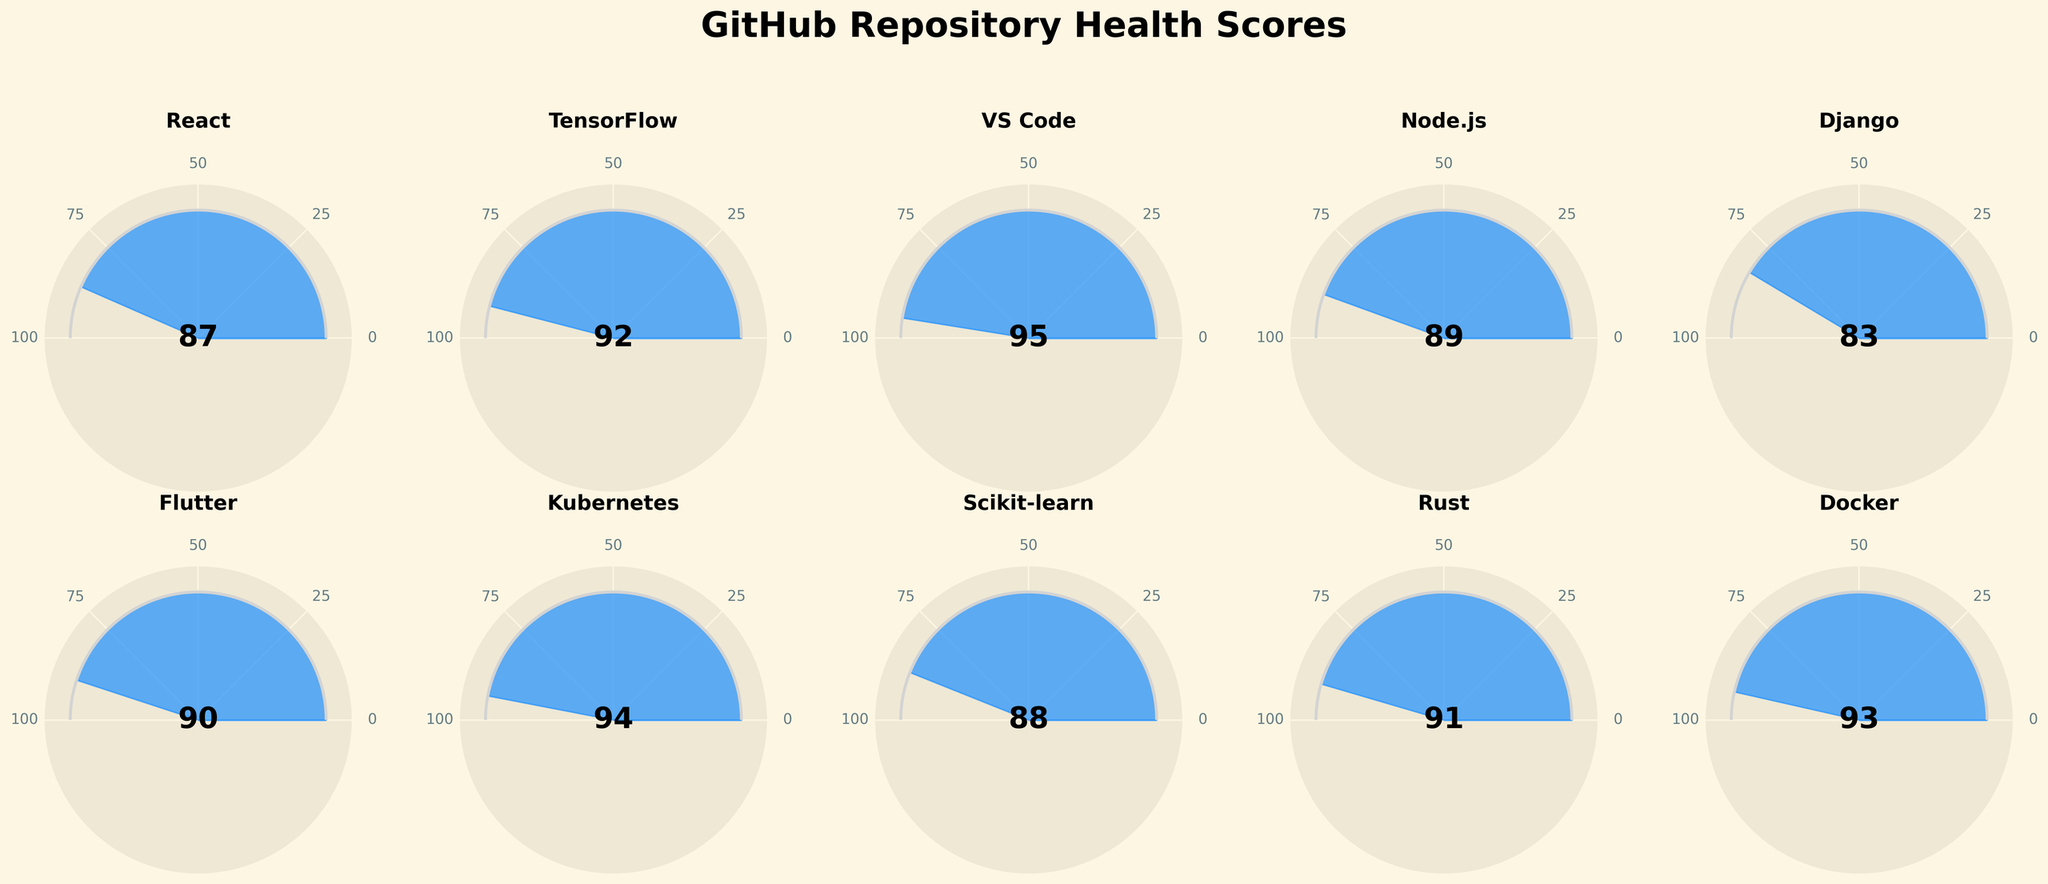What's the title of the figure? The title is typically displayed in a prominent position, often at the top of the figure. In this figure, it reads "GitHub Repository Health Scores."
Answer: GitHub Repository Health Scores How many repositories are displayed in the figure? Each gauge chart represents a repository. By counting the individual gauge charts, you can see there are 10 repositories in total.
Answer: 10 Which repository has the highest health score? By examining each gauge chart, you can see the top scores. "VS Code" has the highest score of 95.
Answer: VS Code What's the health score of the Django repository? Locate the gauge chart titled "Django" and note the value displayed inside it, which is 83.
Answer: 83 What's the average health score of all the repositories? Add all scores (87 + 92 + 95 + 89 + 83 + 90 + 94 + 88 + 91 + 93) to get 902, then divide by the total number of repositories (10) to get the average. 902/10 = 90.2.
Answer: 90.2 How many repositories have a health score above 90? Count the gauge charts where the score is greater than 90. There are 6 repositories with scores above 90: TensorFlow, VS Code, Flutter, Kubernetes, Rust, and Docker.
Answer: 6 Which two repositories have the closest health scores? Compare all pairs of scores to find the smallest difference. React (87) and Scikit-learn (88) have the closest scores with a difference of 1.
Answer: React and Scikit-learn Which repository has the lowest health score? By comparing the scores, you can see that the "Django" repository has the lowest score, which is 83.
Answer: Django What's the difference in the health score between Kubernetes and Node.js? Subtract the lower score from the higher score. Kubernetes has 94, and Node.js has 89. So, 94 - 89 = 5.
Answer: 5 Is the health score of Rust repository higher than Docker? Compare the scores of Rust (91) and Docker (93). Rust’s score is lower than Docker’s score.
Answer: No 